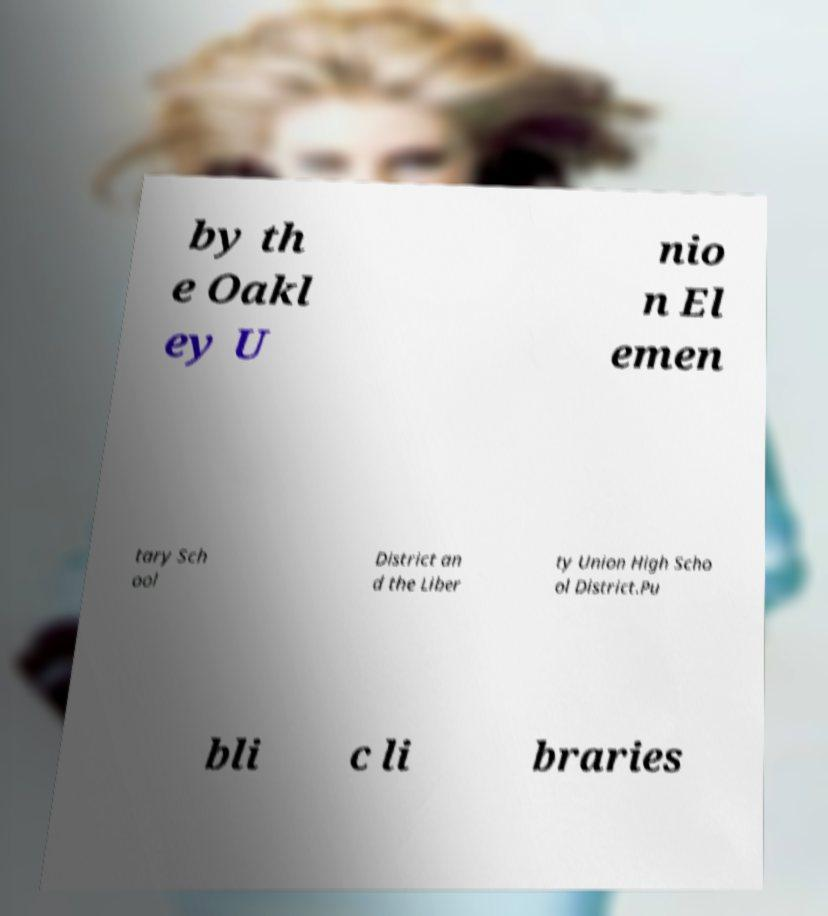For documentation purposes, I need the text within this image transcribed. Could you provide that? by th e Oakl ey U nio n El emen tary Sch ool District an d the Liber ty Union High Scho ol District.Pu bli c li braries 